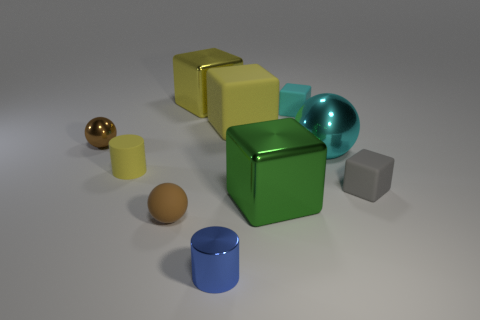Are there fewer small blue metal things that are in front of the tiny yellow matte cylinder than small cyan cylinders?
Ensure brevity in your answer.  No. What color is the matte block to the left of the green cube?
Make the answer very short. Yellow. What is the material of the thing that is the same color as the large metallic sphere?
Your answer should be compact. Rubber. Are there any tiny blue objects of the same shape as the big yellow matte object?
Ensure brevity in your answer.  No. How many tiny yellow rubber things are the same shape as the large cyan thing?
Your answer should be compact. 0. Is the color of the large matte object the same as the rubber ball?
Your answer should be compact. No. Are there fewer large green metallic spheres than cyan metallic spheres?
Your answer should be very brief. Yes. There is a tiny sphere that is on the left side of the brown rubber object; what material is it?
Keep it short and to the point. Metal. What is the material of the green thing that is the same size as the cyan ball?
Keep it short and to the point. Metal. The block that is to the right of the cyan matte cube that is behind the metal sphere to the right of the large yellow metal block is made of what material?
Ensure brevity in your answer.  Rubber. 